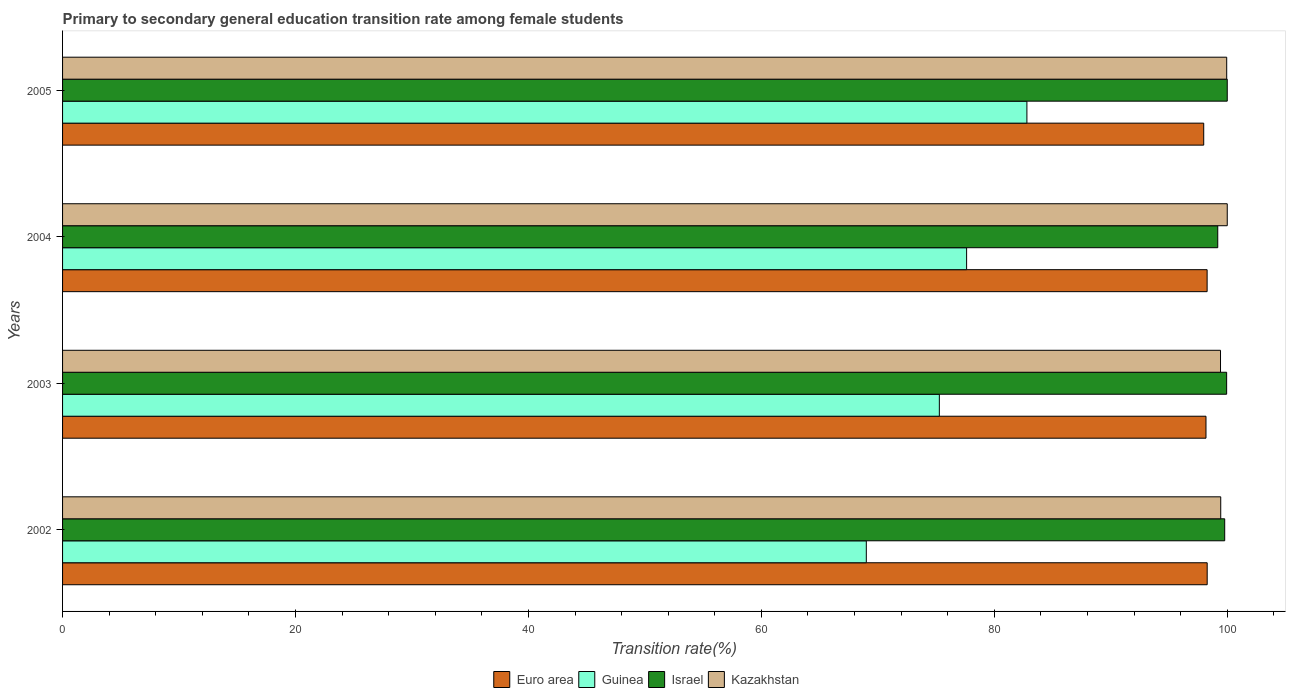How many different coloured bars are there?
Offer a very short reply. 4. How many groups of bars are there?
Keep it short and to the point. 4. Are the number of bars per tick equal to the number of legend labels?
Offer a terse response. Yes. How many bars are there on the 2nd tick from the top?
Provide a succinct answer. 4. How many bars are there on the 4th tick from the bottom?
Your response must be concise. 4. What is the label of the 4th group of bars from the top?
Your response must be concise. 2002. In how many cases, is the number of bars for a given year not equal to the number of legend labels?
Offer a terse response. 0. What is the transition rate in Guinea in 2002?
Ensure brevity in your answer.  69.01. Across all years, what is the maximum transition rate in Euro area?
Provide a succinct answer. 98.28. Across all years, what is the minimum transition rate in Kazakhstan?
Your response must be concise. 99.42. In which year was the transition rate in Euro area maximum?
Make the answer very short. 2002. What is the total transition rate in Euro area in the graph?
Provide a short and direct response. 392.7. What is the difference between the transition rate in Israel in 2002 and that in 2005?
Your response must be concise. -0.22. What is the difference between the transition rate in Guinea in 2003 and the transition rate in Euro area in 2002?
Your response must be concise. -23. What is the average transition rate in Guinea per year?
Your answer should be compact. 76.18. In the year 2005, what is the difference between the transition rate in Israel and transition rate in Kazakhstan?
Offer a terse response. 0.05. In how many years, is the transition rate in Guinea greater than 52 %?
Provide a short and direct response. 4. What is the ratio of the transition rate in Israel in 2003 to that in 2005?
Provide a short and direct response. 1. Is the difference between the transition rate in Israel in 2002 and 2004 greater than the difference between the transition rate in Kazakhstan in 2002 and 2004?
Offer a terse response. Yes. What is the difference between the highest and the second highest transition rate in Euro area?
Provide a short and direct response. 0.01. What is the difference between the highest and the lowest transition rate in Israel?
Provide a succinct answer. 0.82. In how many years, is the transition rate in Guinea greater than the average transition rate in Guinea taken over all years?
Give a very brief answer. 2. Is it the case that in every year, the sum of the transition rate in Euro area and transition rate in Kazakhstan is greater than the sum of transition rate in Israel and transition rate in Guinea?
Your response must be concise. No. What does the 4th bar from the top in 2002 represents?
Your answer should be compact. Euro area. What is the difference between two consecutive major ticks on the X-axis?
Ensure brevity in your answer.  20. Does the graph contain grids?
Offer a terse response. No. Where does the legend appear in the graph?
Your answer should be very brief. Bottom center. What is the title of the graph?
Offer a very short reply. Primary to secondary general education transition rate among female students. What is the label or title of the X-axis?
Offer a terse response. Transition rate(%). What is the Transition rate(%) of Euro area in 2002?
Offer a terse response. 98.28. What is the Transition rate(%) in Guinea in 2002?
Make the answer very short. 69.01. What is the Transition rate(%) in Israel in 2002?
Offer a terse response. 99.78. What is the Transition rate(%) of Kazakhstan in 2002?
Give a very brief answer. 99.44. What is the Transition rate(%) in Euro area in 2003?
Provide a short and direct response. 98.17. What is the Transition rate(%) of Guinea in 2003?
Ensure brevity in your answer.  75.28. What is the Transition rate(%) in Israel in 2003?
Make the answer very short. 99.95. What is the Transition rate(%) of Kazakhstan in 2003?
Offer a very short reply. 99.42. What is the Transition rate(%) in Euro area in 2004?
Keep it short and to the point. 98.27. What is the Transition rate(%) of Guinea in 2004?
Provide a succinct answer. 77.62. What is the Transition rate(%) in Israel in 2004?
Offer a terse response. 99.18. What is the Transition rate(%) of Kazakhstan in 2004?
Your answer should be compact. 100. What is the Transition rate(%) of Euro area in 2005?
Provide a short and direct response. 97.98. What is the Transition rate(%) in Guinea in 2005?
Provide a succinct answer. 82.8. What is the Transition rate(%) of Kazakhstan in 2005?
Offer a very short reply. 99.95. Across all years, what is the maximum Transition rate(%) of Euro area?
Your answer should be compact. 98.28. Across all years, what is the maximum Transition rate(%) of Guinea?
Ensure brevity in your answer.  82.8. Across all years, what is the maximum Transition rate(%) of Kazakhstan?
Give a very brief answer. 100. Across all years, what is the minimum Transition rate(%) of Euro area?
Your answer should be compact. 97.98. Across all years, what is the minimum Transition rate(%) in Guinea?
Offer a terse response. 69.01. Across all years, what is the minimum Transition rate(%) of Israel?
Your response must be concise. 99.18. Across all years, what is the minimum Transition rate(%) in Kazakhstan?
Your answer should be compact. 99.42. What is the total Transition rate(%) of Euro area in the graph?
Provide a short and direct response. 392.7. What is the total Transition rate(%) in Guinea in the graph?
Your answer should be compact. 304.71. What is the total Transition rate(%) in Israel in the graph?
Your answer should be compact. 398.91. What is the total Transition rate(%) of Kazakhstan in the graph?
Keep it short and to the point. 398.81. What is the difference between the Transition rate(%) of Euro area in 2002 and that in 2003?
Your response must be concise. 0.1. What is the difference between the Transition rate(%) in Guinea in 2002 and that in 2003?
Your response must be concise. -6.27. What is the difference between the Transition rate(%) of Israel in 2002 and that in 2003?
Your response must be concise. -0.17. What is the difference between the Transition rate(%) in Kazakhstan in 2002 and that in 2003?
Your response must be concise. 0.02. What is the difference between the Transition rate(%) in Euro area in 2002 and that in 2004?
Your response must be concise. 0.01. What is the difference between the Transition rate(%) of Guinea in 2002 and that in 2004?
Provide a succinct answer. -8.61. What is the difference between the Transition rate(%) in Israel in 2002 and that in 2004?
Your answer should be compact. 0.6. What is the difference between the Transition rate(%) of Kazakhstan in 2002 and that in 2004?
Your answer should be compact. -0.56. What is the difference between the Transition rate(%) in Euro area in 2002 and that in 2005?
Your response must be concise. 0.3. What is the difference between the Transition rate(%) of Guinea in 2002 and that in 2005?
Your answer should be compact. -13.79. What is the difference between the Transition rate(%) in Israel in 2002 and that in 2005?
Offer a terse response. -0.22. What is the difference between the Transition rate(%) in Kazakhstan in 2002 and that in 2005?
Offer a terse response. -0.51. What is the difference between the Transition rate(%) in Euro area in 2003 and that in 2004?
Offer a very short reply. -0.1. What is the difference between the Transition rate(%) of Guinea in 2003 and that in 2004?
Offer a very short reply. -2.34. What is the difference between the Transition rate(%) in Israel in 2003 and that in 2004?
Make the answer very short. 0.76. What is the difference between the Transition rate(%) of Kazakhstan in 2003 and that in 2004?
Offer a very short reply. -0.58. What is the difference between the Transition rate(%) in Euro area in 2003 and that in 2005?
Your response must be concise. 0.19. What is the difference between the Transition rate(%) of Guinea in 2003 and that in 2005?
Give a very brief answer. -7.52. What is the difference between the Transition rate(%) in Israel in 2003 and that in 2005?
Offer a very short reply. -0.05. What is the difference between the Transition rate(%) of Kazakhstan in 2003 and that in 2005?
Provide a short and direct response. -0.53. What is the difference between the Transition rate(%) in Euro area in 2004 and that in 2005?
Your response must be concise. 0.29. What is the difference between the Transition rate(%) of Guinea in 2004 and that in 2005?
Offer a very short reply. -5.18. What is the difference between the Transition rate(%) in Israel in 2004 and that in 2005?
Make the answer very short. -0.82. What is the difference between the Transition rate(%) of Kazakhstan in 2004 and that in 2005?
Ensure brevity in your answer.  0.05. What is the difference between the Transition rate(%) of Euro area in 2002 and the Transition rate(%) of Guinea in 2003?
Your response must be concise. 23. What is the difference between the Transition rate(%) of Euro area in 2002 and the Transition rate(%) of Israel in 2003?
Offer a very short reply. -1.67. What is the difference between the Transition rate(%) of Euro area in 2002 and the Transition rate(%) of Kazakhstan in 2003?
Provide a succinct answer. -1.14. What is the difference between the Transition rate(%) in Guinea in 2002 and the Transition rate(%) in Israel in 2003?
Provide a short and direct response. -30.94. What is the difference between the Transition rate(%) of Guinea in 2002 and the Transition rate(%) of Kazakhstan in 2003?
Ensure brevity in your answer.  -30.41. What is the difference between the Transition rate(%) of Israel in 2002 and the Transition rate(%) of Kazakhstan in 2003?
Ensure brevity in your answer.  0.36. What is the difference between the Transition rate(%) of Euro area in 2002 and the Transition rate(%) of Guinea in 2004?
Give a very brief answer. 20.66. What is the difference between the Transition rate(%) of Euro area in 2002 and the Transition rate(%) of Israel in 2004?
Offer a terse response. -0.91. What is the difference between the Transition rate(%) of Euro area in 2002 and the Transition rate(%) of Kazakhstan in 2004?
Ensure brevity in your answer.  -1.72. What is the difference between the Transition rate(%) of Guinea in 2002 and the Transition rate(%) of Israel in 2004?
Make the answer very short. -30.17. What is the difference between the Transition rate(%) in Guinea in 2002 and the Transition rate(%) in Kazakhstan in 2004?
Your response must be concise. -30.99. What is the difference between the Transition rate(%) in Israel in 2002 and the Transition rate(%) in Kazakhstan in 2004?
Offer a very short reply. -0.22. What is the difference between the Transition rate(%) of Euro area in 2002 and the Transition rate(%) of Guinea in 2005?
Offer a terse response. 15.48. What is the difference between the Transition rate(%) of Euro area in 2002 and the Transition rate(%) of Israel in 2005?
Provide a succinct answer. -1.72. What is the difference between the Transition rate(%) of Euro area in 2002 and the Transition rate(%) of Kazakhstan in 2005?
Give a very brief answer. -1.68. What is the difference between the Transition rate(%) in Guinea in 2002 and the Transition rate(%) in Israel in 2005?
Keep it short and to the point. -30.99. What is the difference between the Transition rate(%) in Guinea in 2002 and the Transition rate(%) in Kazakhstan in 2005?
Provide a short and direct response. -30.94. What is the difference between the Transition rate(%) of Israel in 2002 and the Transition rate(%) of Kazakhstan in 2005?
Ensure brevity in your answer.  -0.17. What is the difference between the Transition rate(%) of Euro area in 2003 and the Transition rate(%) of Guinea in 2004?
Make the answer very short. 20.55. What is the difference between the Transition rate(%) in Euro area in 2003 and the Transition rate(%) in Israel in 2004?
Your answer should be very brief. -1.01. What is the difference between the Transition rate(%) of Euro area in 2003 and the Transition rate(%) of Kazakhstan in 2004?
Your answer should be very brief. -1.83. What is the difference between the Transition rate(%) in Guinea in 2003 and the Transition rate(%) in Israel in 2004?
Ensure brevity in your answer.  -23.9. What is the difference between the Transition rate(%) in Guinea in 2003 and the Transition rate(%) in Kazakhstan in 2004?
Provide a succinct answer. -24.72. What is the difference between the Transition rate(%) in Israel in 2003 and the Transition rate(%) in Kazakhstan in 2004?
Your response must be concise. -0.05. What is the difference between the Transition rate(%) of Euro area in 2003 and the Transition rate(%) of Guinea in 2005?
Offer a terse response. 15.37. What is the difference between the Transition rate(%) of Euro area in 2003 and the Transition rate(%) of Israel in 2005?
Ensure brevity in your answer.  -1.83. What is the difference between the Transition rate(%) of Euro area in 2003 and the Transition rate(%) of Kazakhstan in 2005?
Give a very brief answer. -1.78. What is the difference between the Transition rate(%) of Guinea in 2003 and the Transition rate(%) of Israel in 2005?
Your answer should be compact. -24.72. What is the difference between the Transition rate(%) in Guinea in 2003 and the Transition rate(%) in Kazakhstan in 2005?
Make the answer very short. -24.67. What is the difference between the Transition rate(%) in Israel in 2003 and the Transition rate(%) in Kazakhstan in 2005?
Provide a succinct answer. -0.01. What is the difference between the Transition rate(%) in Euro area in 2004 and the Transition rate(%) in Guinea in 2005?
Your answer should be very brief. 15.47. What is the difference between the Transition rate(%) of Euro area in 2004 and the Transition rate(%) of Israel in 2005?
Offer a very short reply. -1.73. What is the difference between the Transition rate(%) in Euro area in 2004 and the Transition rate(%) in Kazakhstan in 2005?
Your answer should be very brief. -1.68. What is the difference between the Transition rate(%) of Guinea in 2004 and the Transition rate(%) of Israel in 2005?
Provide a succinct answer. -22.38. What is the difference between the Transition rate(%) of Guinea in 2004 and the Transition rate(%) of Kazakhstan in 2005?
Offer a terse response. -22.33. What is the difference between the Transition rate(%) in Israel in 2004 and the Transition rate(%) in Kazakhstan in 2005?
Your response must be concise. -0.77. What is the average Transition rate(%) in Euro area per year?
Offer a very short reply. 98.17. What is the average Transition rate(%) in Guinea per year?
Make the answer very short. 76.18. What is the average Transition rate(%) of Israel per year?
Offer a very short reply. 99.73. What is the average Transition rate(%) of Kazakhstan per year?
Provide a succinct answer. 99.7. In the year 2002, what is the difference between the Transition rate(%) in Euro area and Transition rate(%) in Guinea?
Provide a succinct answer. 29.27. In the year 2002, what is the difference between the Transition rate(%) in Euro area and Transition rate(%) in Israel?
Ensure brevity in your answer.  -1.5. In the year 2002, what is the difference between the Transition rate(%) of Euro area and Transition rate(%) of Kazakhstan?
Keep it short and to the point. -1.16. In the year 2002, what is the difference between the Transition rate(%) of Guinea and Transition rate(%) of Israel?
Your answer should be compact. -30.77. In the year 2002, what is the difference between the Transition rate(%) of Guinea and Transition rate(%) of Kazakhstan?
Offer a terse response. -30.43. In the year 2002, what is the difference between the Transition rate(%) in Israel and Transition rate(%) in Kazakhstan?
Offer a very short reply. 0.34. In the year 2003, what is the difference between the Transition rate(%) in Euro area and Transition rate(%) in Guinea?
Your answer should be very brief. 22.89. In the year 2003, what is the difference between the Transition rate(%) of Euro area and Transition rate(%) of Israel?
Your answer should be compact. -1.77. In the year 2003, what is the difference between the Transition rate(%) in Euro area and Transition rate(%) in Kazakhstan?
Your answer should be very brief. -1.25. In the year 2003, what is the difference between the Transition rate(%) of Guinea and Transition rate(%) of Israel?
Keep it short and to the point. -24.67. In the year 2003, what is the difference between the Transition rate(%) of Guinea and Transition rate(%) of Kazakhstan?
Provide a succinct answer. -24.14. In the year 2003, what is the difference between the Transition rate(%) of Israel and Transition rate(%) of Kazakhstan?
Provide a short and direct response. 0.53. In the year 2004, what is the difference between the Transition rate(%) in Euro area and Transition rate(%) in Guinea?
Offer a terse response. 20.65. In the year 2004, what is the difference between the Transition rate(%) in Euro area and Transition rate(%) in Israel?
Keep it short and to the point. -0.91. In the year 2004, what is the difference between the Transition rate(%) of Euro area and Transition rate(%) of Kazakhstan?
Ensure brevity in your answer.  -1.73. In the year 2004, what is the difference between the Transition rate(%) in Guinea and Transition rate(%) in Israel?
Your answer should be compact. -21.56. In the year 2004, what is the difference between the Transition rate(%) of Guinea and Transition rate(%) of Kazakhstan?
Make the answer very short. -22.38. In the year 2004, what is the difference between the Transition rate(%) of Israel and Transition rate(%) of Kazakhstan?
Ensure brevity in your answer.  -0.82. In the year 2005, what is the difference between the Transition rate(%) of Euro area and Transition rate(%) of Guinea?
Your answer should be compact. 15.18. In the year 2005, what is the difference between the Transition rate(%) in Euro area and Transition rate(%) in Israel?
Keep it short and to the point. -2.02. In the year 2005, what is the difference between the Transition rate(%) in Euro area and Transition rate(%) in Kazakhstan?
Offer a very short reply. -1.97. In the year 2005, what is the difference between the Transition rate(%) of Guinea and Transition rate(%) of Israel?
Ensure brevity in your answer.  -17.2. In the year 2005, what is the difference between the Transition rate(%) of Guinea and Transition rate(%) of Kazakhstan?
Your answer should be compact. -17.15. In the year 2005, what is the difference between the Transition rate(%) of Israel and Transition rate(%) of Kazakhstan?
Offer a terse response. 0.05. What is the ratio of the Transition rate(%) of Euro area in 2002 to that in 2003?
Ensure brevity in your answer.  1. What is the ratio of the Transition rate(%) in Israel in 2002 to that in 2003?
Give a very brief answer. 1. What is the ratio of the Transition rate(%) in Kazakhstan in 2002 to that in 2003?
Your answer should be compact. 1. What is the ratio of the Transition rate(%) in Guinea in 2002 to that in 2004?
Ensure brevity in your answer.  0.89. What is the ratio of the Transition rate(%) in Israel in 2002 to that in 2004?
Make the answer very short. 1.01. What is the ratio of the Transition rate(%) in Euro area in 2002 to that in 2005?
Offer a terse response. 1. What is the ratio of the Transition rate(%) in Guinea in 2002 to that in 2005?
Offer a terse response. 0.83. What is the ratio of the Transition rate(%) of Guinea in 2003 to that in 2004?
Keep it short and to the point. 0.97. What is the ratio of the Transition rate(%) of Israel in 2003 to that in 2004?
Make the answer very short. 1.01. What is the ratio of the Transition rate(%) in Guinea in 2003 to that in 2005?
Your answer should be very brief. 0.91. What is the ratio of the Transition rate(%) in Israel in 2003 to that in 2005?
Provide a succinct answer. 1. What is the ratio of the Transition rate(%) in Kazakhstan in 2003 to that in 2005?
Provide a short and direct response. 0.99. What is the ratio of the Transition rate(%) of Euro area in 2004 to that in 2005?
Offer a terse response. 1. What is the ratio of the Transition rate(%) of Guinea in 2004 to that in 2005?
Offer a terse response. 0.94. What is the ratio of the Transition rate(%) in Kazakhstan in 2004 to that in 2005?
Your answer should be very brief. 1. What is the difference between the highest and the second highest Transition rate(%) in Euro area?
Your answer should be very brief. 0.01. What is the difference between the highest and the second highest Transition rate(%) of Guinea?
Your answer should be very brief. 5.18. What is the difference between the highest and the second highest Transition rate(%) of Israel?
Your answer should be compact. 0.05. What is the difference between the highest and the second highest Transition rate(%) of Kazakhstan?
Keep it short and to the point. 0.05. What is the difference between the highest and the lowest Transition rate(%) of Euro area?
Your response must be concise. 0.3. What is the difference between the highest and the lowest Transition rate(%) in Guinea?
Your answer should be compact. 13.79. What is the difference between the highest and the lowest Transition rate(%) in Israel?
Your answer should be very brief. 0.82. What is the difference between the highest and the lowest Transition rate(%) of Kazakhstan?
Your response must be concise. 0.58. 